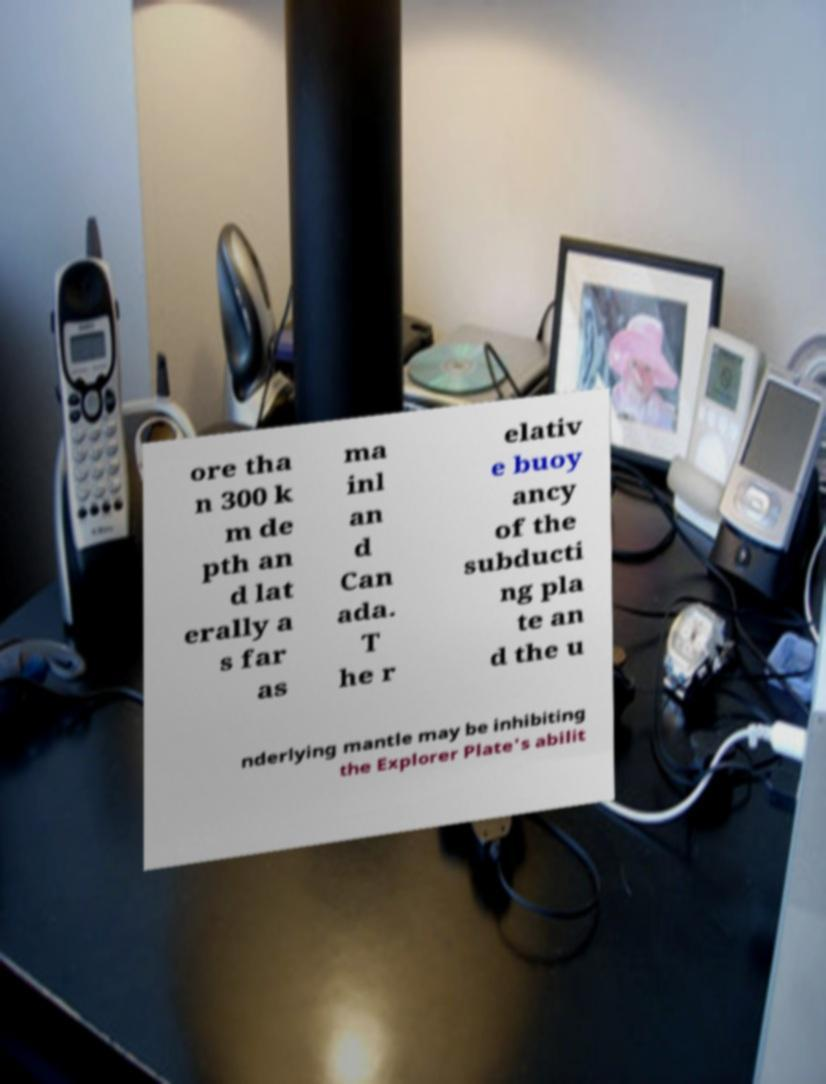Please identify and transcribe the text found in this image. ore tha n 300 k m de pth an d lat erally a s far as ma inl an d Can ada. T he r elativ e buoy ancy of the subducti ng pla te an d the u nderlying mantle may be inhibiting the Explorer Plate's abilit 